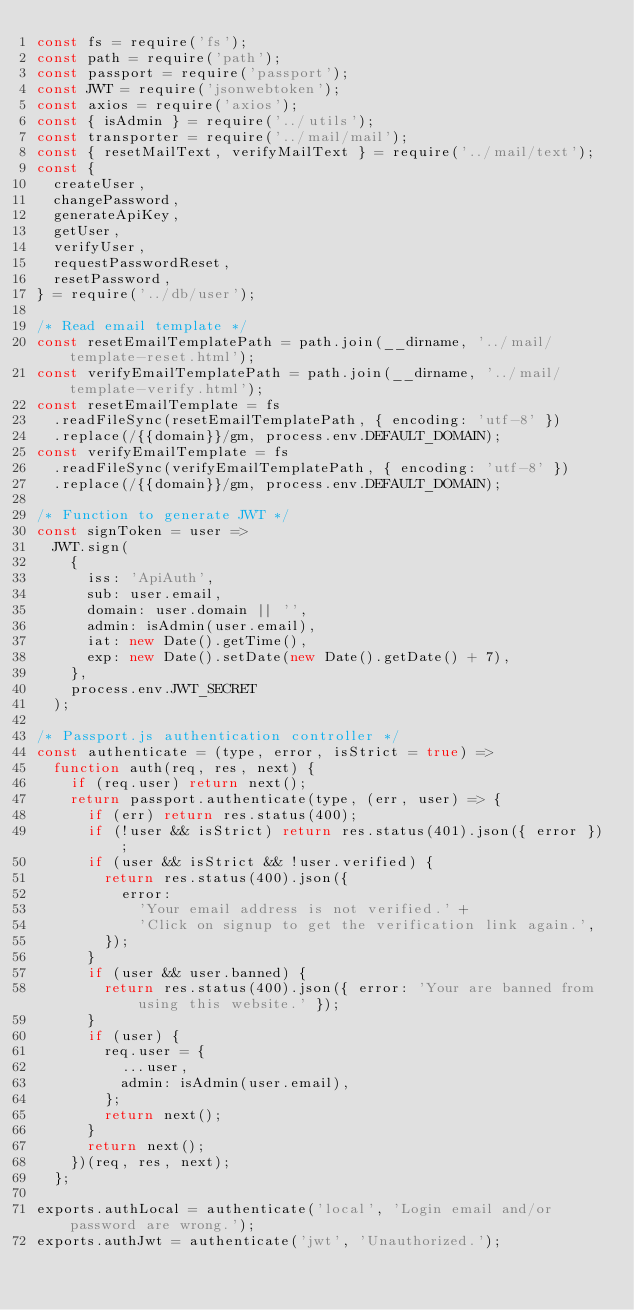<code> <loc_0><loc_0><loc_500><loc_500><_JavaScript_>const fs = require('fs');
const path = require('path');
const passport = require('passport');
const JWT = require('jsonwebtoken');
const axios = require('axios');
const { isAdmin } = require('../utils');
const transporter = require('../mail/mail');
const { resetMailText, verifyMailText } = require('../mail/text');
const {
  createUser,
  changePassword,
  generateApiKey,
  getUser,
  verifyUser,
  requestPasswordReset,
  resetPassword,
} = require('../db/user');

/* Read email template */
const resetEmailTemplatePath = path.join(__dirname, '../mail/template-reset.html');
const verifyEmailTemplatePath = path.join(__dirname, '../mail/template-verify.html');
const resetEmailTemplate = fs
  .readFileSync(resetEmailTemplatePath, { encoding: 'utf-8' })
  .replace(/{{domain}}/gm, process.env.DEFAULT_DOMAIN);
const verifyEmailTemplate = fs
  .readFileSync(verifyEmailTemplatePath, { encoding: 'utf-8' })
  .replace(/{{domain}}/gm, process.env.DEFAULT_DOMAIN);

/* Function to generate JWT */
const signToken = user =>
  JWT.sign(
    {
      iss: 'ApiAuth',
      sub: user.email,
      domain: user.domain || '',
      admin: isAdmin(user.email),
      iat: new Date().getTime(),
      exp: new Date().setDate(new Date().getDate() + 7),
    },
    process.env.JWT_SECRET
  );

/* Passport.js authentication controller */
const authenticate = (type, error, isStrict = true) =>
  function auth(req, res, next) {
    if (req.user) return next();
    return passport.authenticate(type, (err, user) => {
      if (err) return res.status(400);
      if (!user && isStrict) return res.status(401).json({ error });
      if (user && isStrict && !user.verified) {
        return res.status(400).json({
          error:
            'Your email address is not verified.' +
            'Click on signup to get the verification link again.',
        });
      }
      if (user && user.banned) {
        return res.status(400).json({ error: 'Your are banned from using this website.' });
      }
      if (user) {
        req.user = {
          ...user,
          admin: isAdmin(user.email),
        };
        return next();
      }
      return next();
    })(req, res, next);
  };

exports.authLocal = authenticate('local', 'Login email and/or password are wrong.');
exports.authJwt = authenticate('jwt', 'Unauthorized.');</code> 